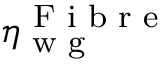<formula> <loc_0><loc_0><loc_500><loc_500>\eta _ { w g } ^ { F i b r e }</formula> 